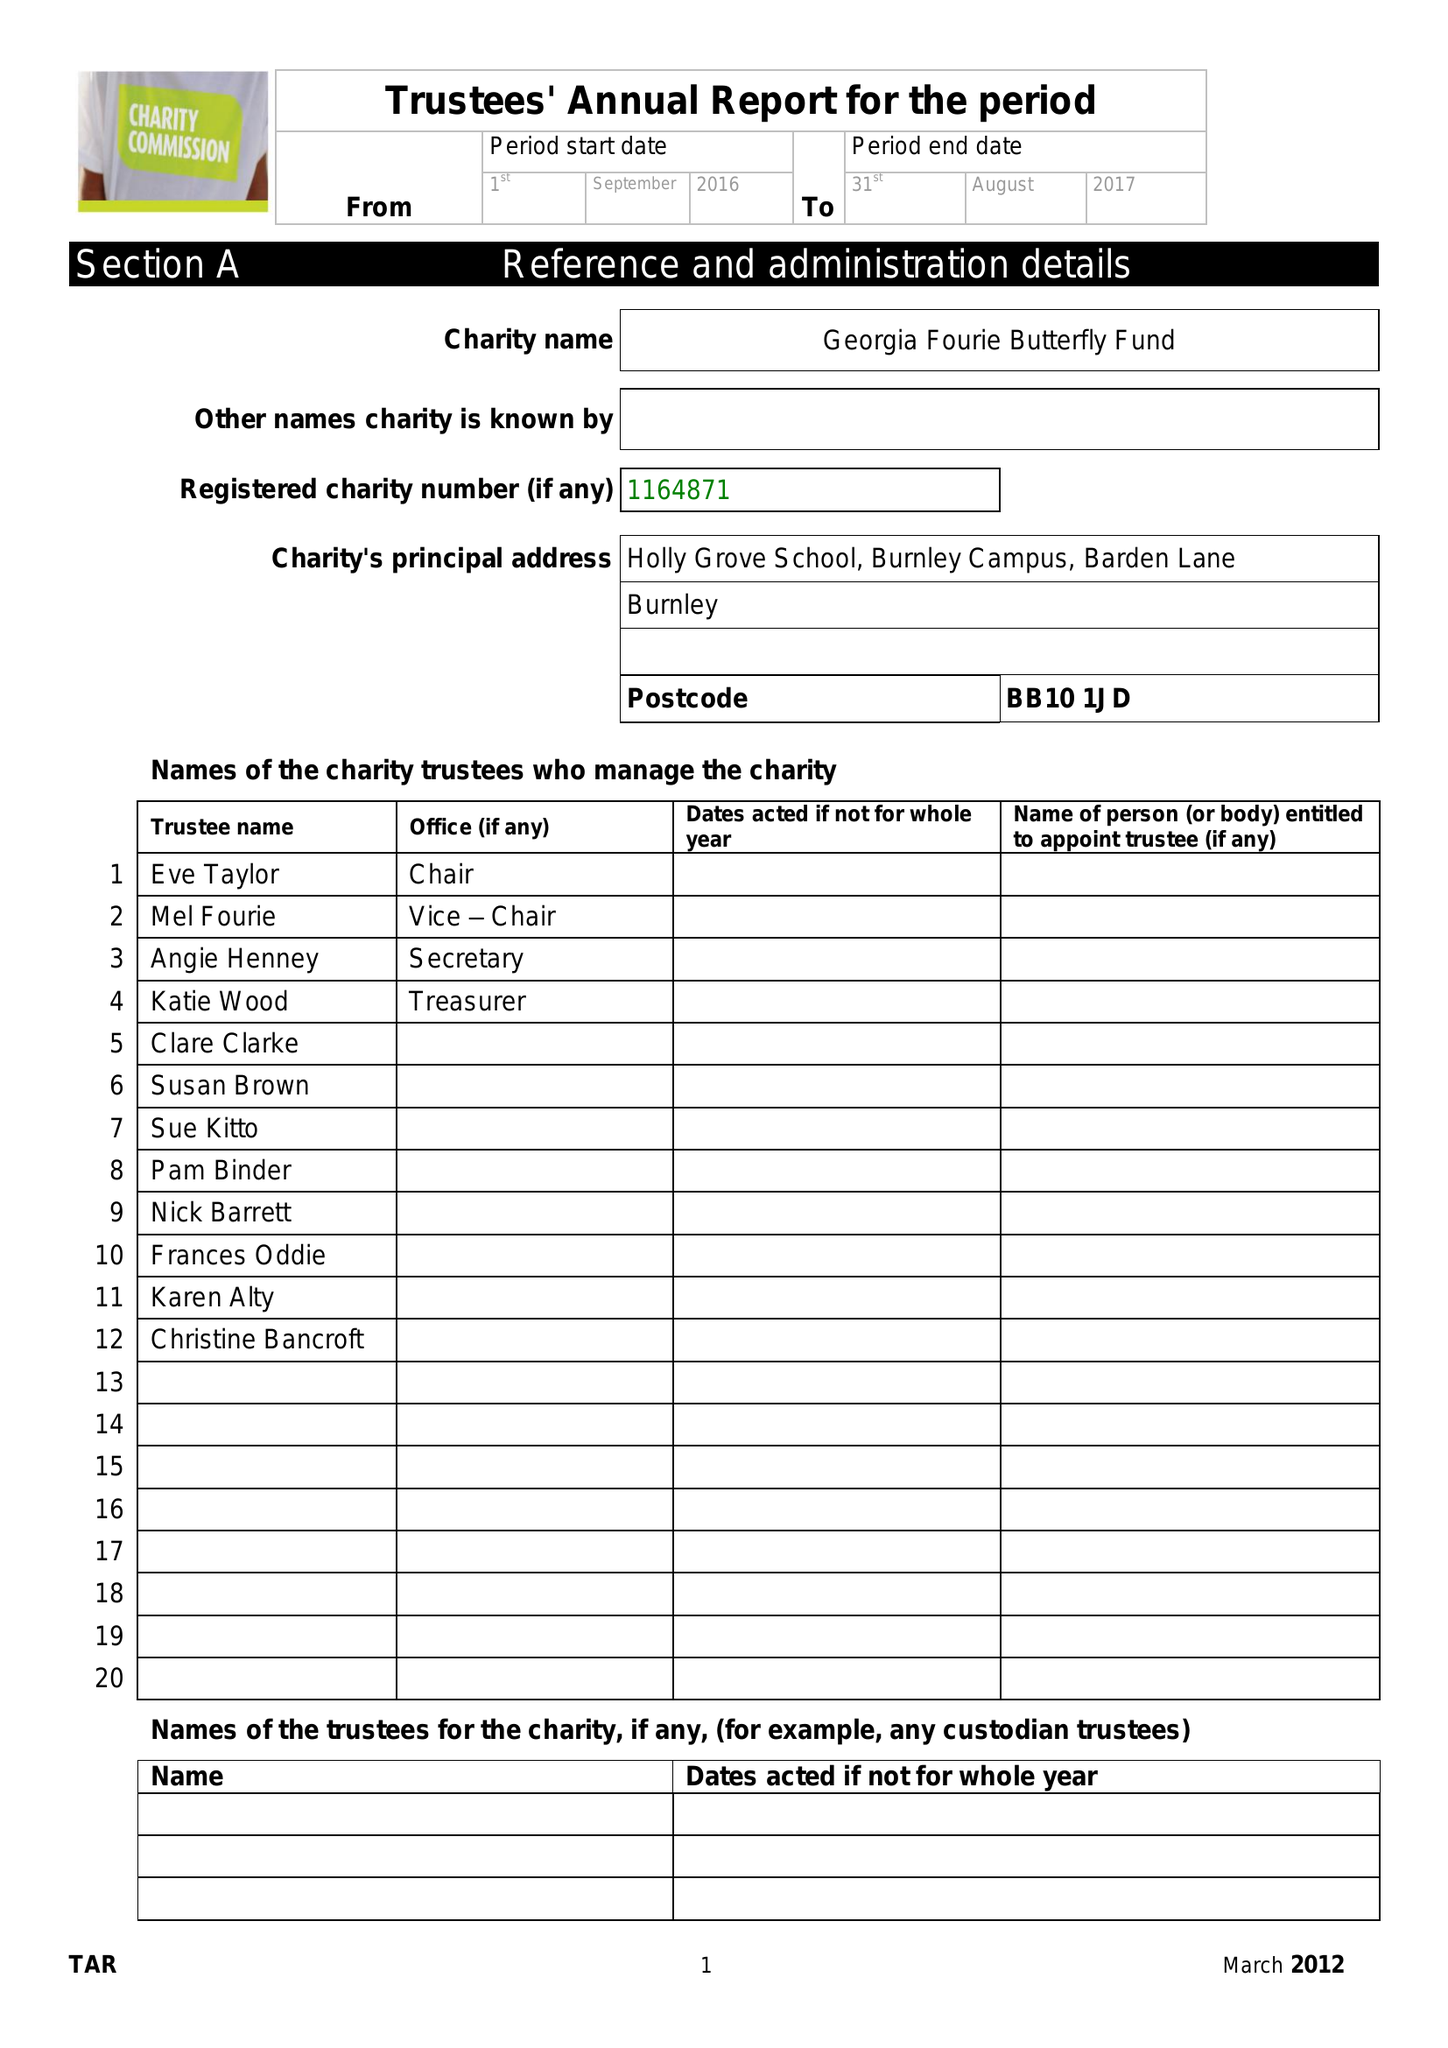What is the value for the spending_annually_in_british_pounds?
Answer the question using a single word or phrase. 11577.00 